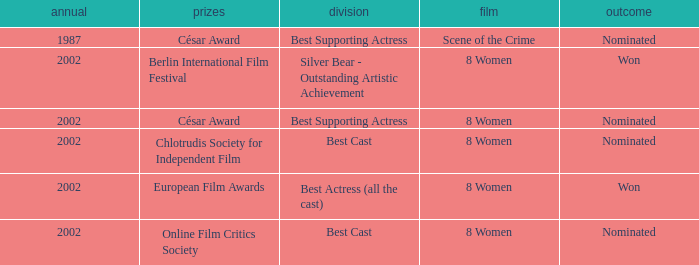What was the result at the Berlin International Film Festival in a year greater than 1987? Won. 